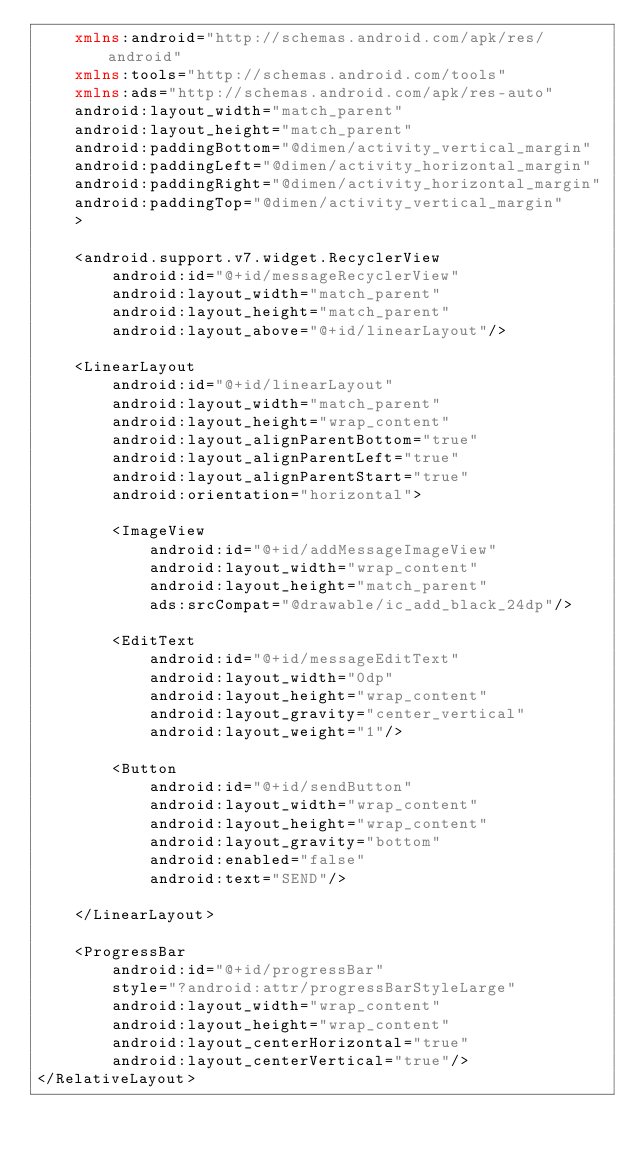<code> <loc_0><loc_0><loc_500><loc_500><_XML_>    xmlns:android="http://schemas.android.com/apk/res/android"
    xmlns:tools="http://schemas.android.com/tools"
    xmlns:ads="http://schemas.android.com/apk/res-auto"
    android:layout_width="match_parent"
    android:layout_height="match_parent"
    android:paddingBottom="@dimen/activity_vertical_margin"
    android:paddingLeft="@dimen/activity_horizontal_margin"
    android:paddingRight="@dimen/activity_horizontal_margin"
    android:paddingTop="@dimen/activity_vertical_margin"
    >

    <android.support.v7.widget.RecyclerView
        android:id="@+id/messageRecyclerView"
        android:layout_width="match_parent"
        android:layout_height="match_parent"
        android:layout_above="@+id/linearLayout"/>

    <LinearLayout
        android:id="@+id/linearLayout"
        android:layout_width="match_parent"
        android:layout_height="wrap_content"
        android:layout_alignParentBottom="true"
        android:layout_alignParentLeft="true"
        android:layout_alignParentStart="true"
        android:orientation="horizontal">

        <ImageView
            android:id="@+id/addMessageImageView"
            android:layout_width="wrap_content"
            android:layout_height="match_parent"
            ads:srcCompat="@drawable/ic_add_black_24dp"/>

        <EditText
            android:id="@+id/messageEditText"
            android:layout_width="0dp"
            android:layout_height="wrap_content"
            android:layout_gravity="center_vertical"
            android:layout_weight="1"/>

        <Button
            android:id="@+id/sendButton"
            android:layout_width="wrap_content"
            android:layout_height="wrap_content"
            android:layout_gravity="bottom"
            android:enabled="false"
            android:text="SEND"/>

    </LinearLayout>

    <ProgressBar
        android:id="@+id/progressBar"
        style="?android:attr/progressBarStyleLarge"
        android:layout_width="wrap_content"
        android:layout_height="wrap_content"
        android:layout_centerHorizontal="true"
        android:layout_centerVertical="true"/>
</RelativeLayout>
</code> 